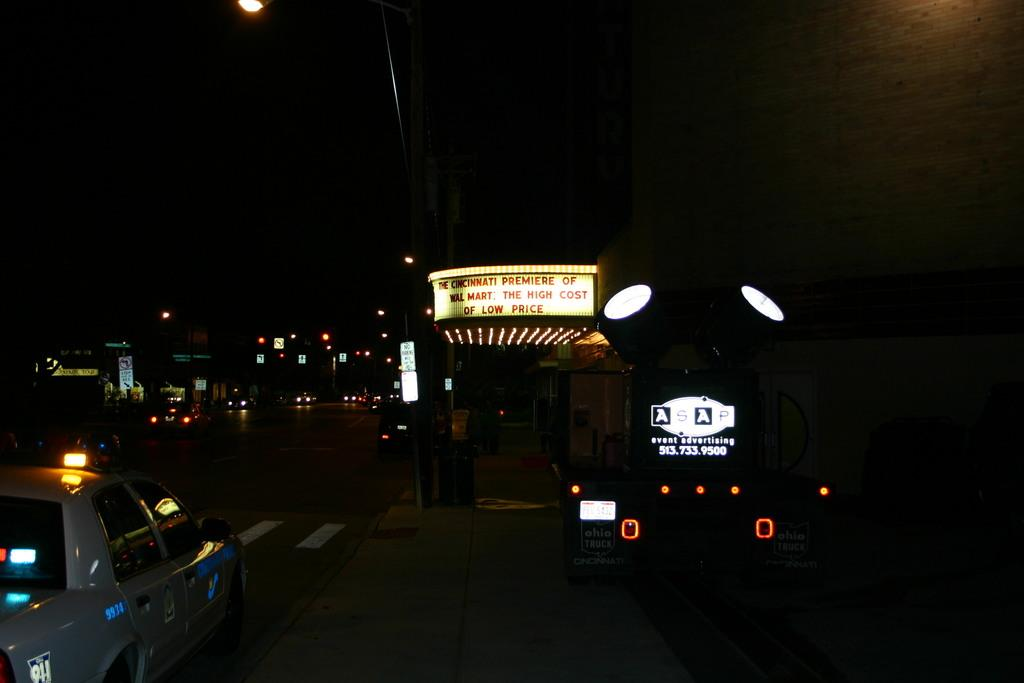<image>
Write a terse but informative summary of the picture. A marquee advertises the Cincinnati premiere of the movie Wal Mart: The High Cost of Low Price. 